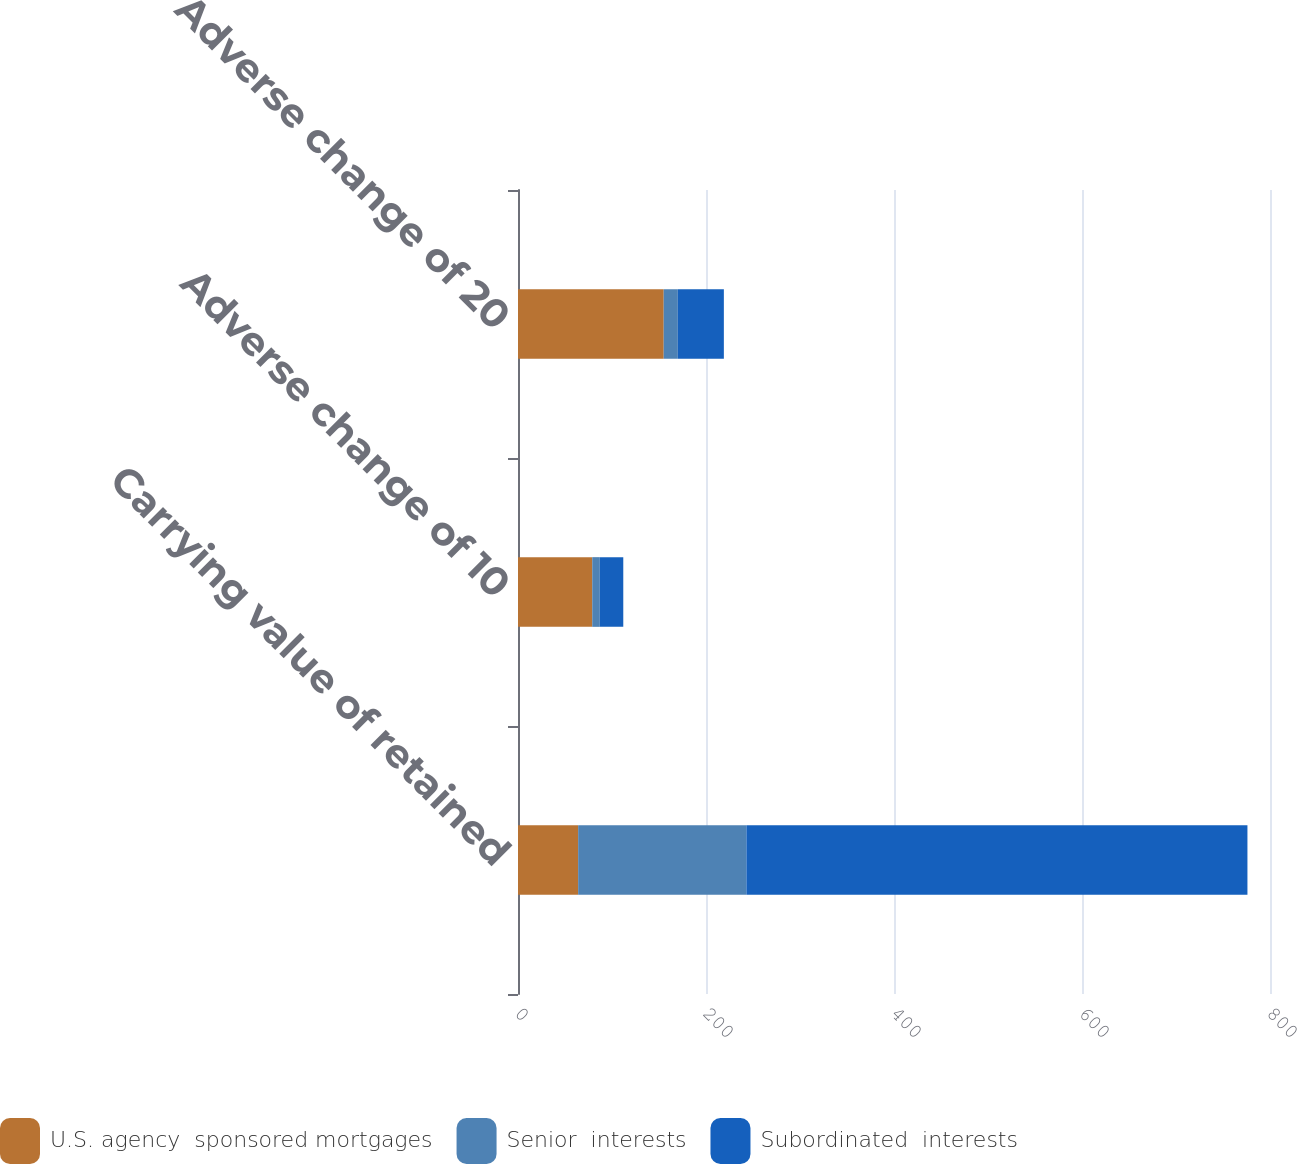Convert chart. <chart><loc_0><loc_0><loc_500><loc_500><stacked_bar_chart><ecel><fcel>Carrying value of retained<fcel>Adverse change of 10<fcel>Adverse change of 20<nl><fcel>U.S. agency  sponsored mortgages<fcel>64<fcel>79<fcel>155<nl><fcel>Senior  interests<fcel>179<fcel>8<fcel>15<nl><fcel>Subordinated  interests<fcel>533<fcel>25<fcel>49<nl></chart> 